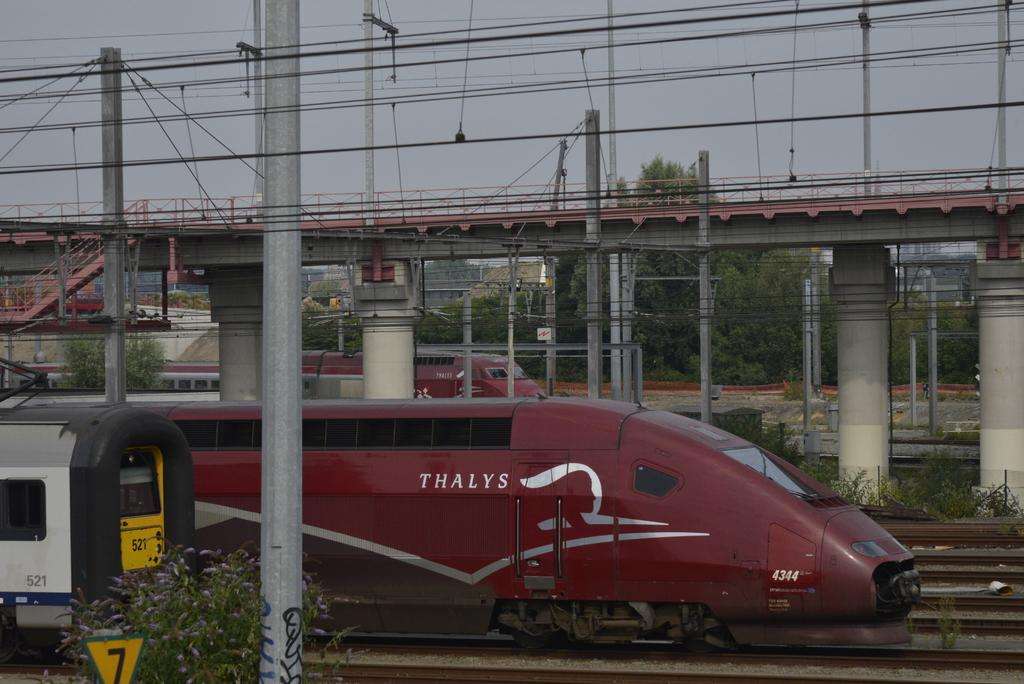<image>
Render a clear and concise summary of the photo. A maroon thalys train behind another car 521 of another train. 